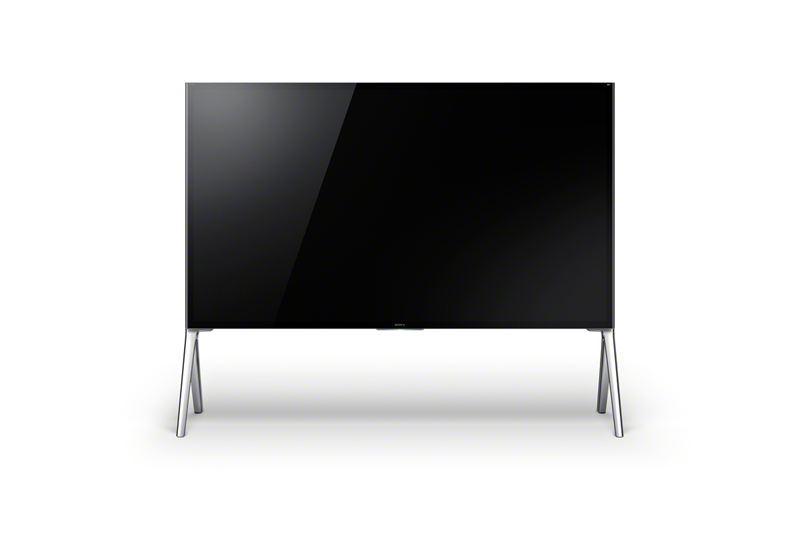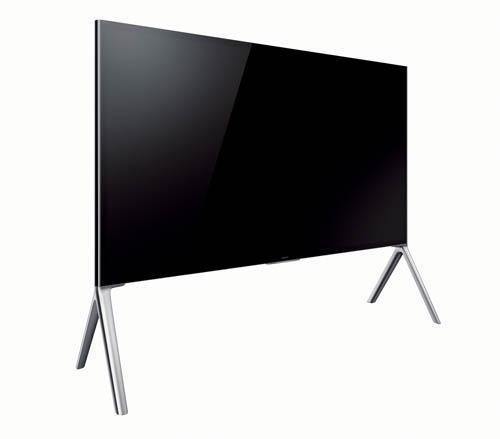The first image is the image on the left, the second image is the image on the right. For the images shown, is this caption "Each image shows one black-screened TV elevated by chrome legs." true? Answer yes or no. Yes. The first image is the image on the left, the second image is the image on the right. For the images displayed, is the sentence "In one of the images, the TV is showing a colorful display." factually correct? Answer yes or no. No. 